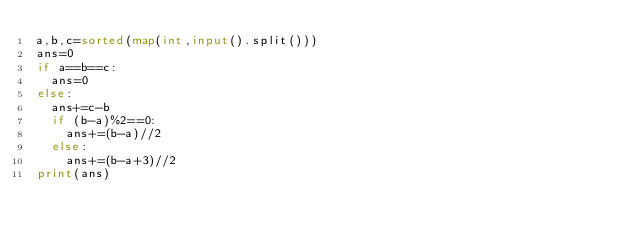<code> <loc_0><loc_0><loc_500><loc_500><_Python_>a,b,c=sorted(map(int,input().split()))
ans=0
if a==b==c:
  ans=0
else:
  ans+=c-b
  if (b-a)%2==0:
    ans+=(b-a)//2
  else:
    ans+=(b-a+3)//2
print(ans)</code> 